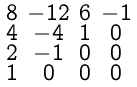<formula> <loc_0><loc_0><loc_500><loc_500>\begin{smallmatrix} 8 & - 1 2 & 6 & - 1 \\ 4 & - 4 & 1 & 0 \\ 2 & - 1 & 0 & 0 \\ 1 & 0 & 0 & 0 \end{smallmatrix}</formula> 